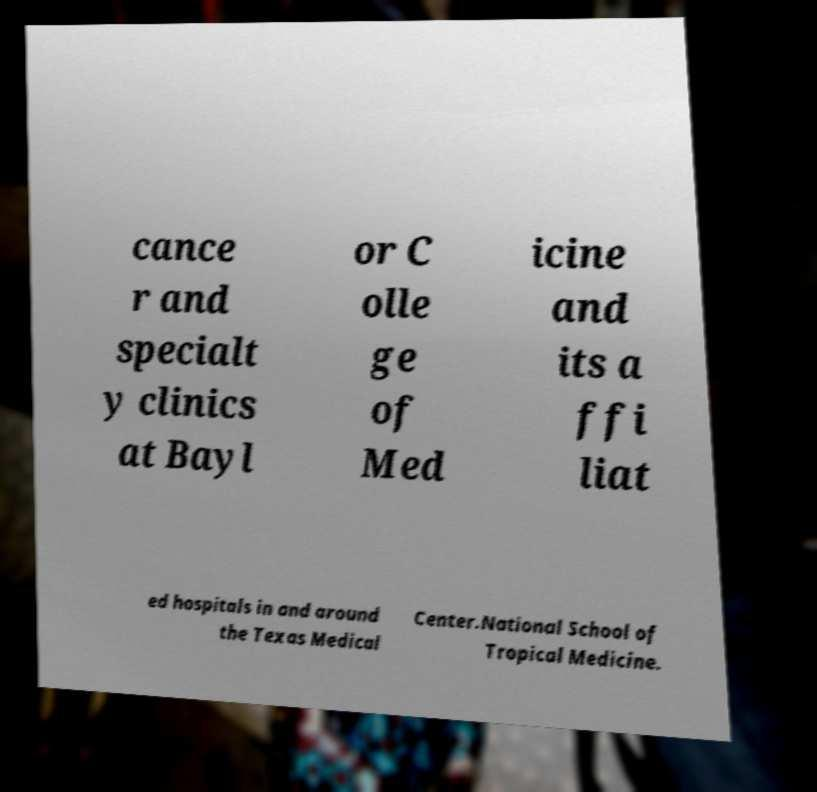Can you accurately transcribe the text from the provided image for me? cance r and specialt y clinics at Bayl or C olle ge of Med icine and its a ffi liat ed hospitals in and around the Texas Medical Center.National School of Tropical Medicine. 